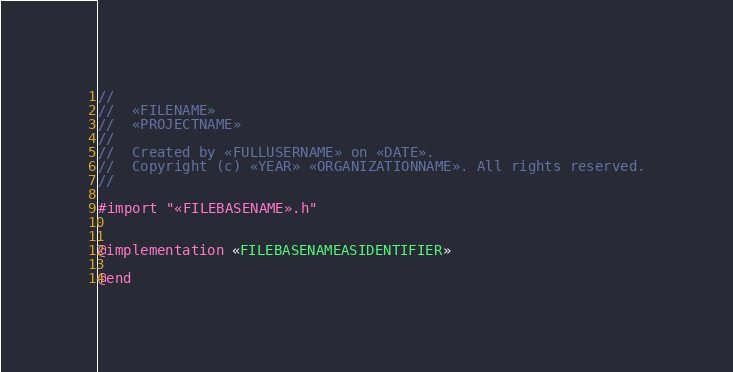Convert code to text. <code><loc_0><loc_0><loc_500><loc_500><_ObjectiveC_>//
//  «FILENAME»
//  «PROJECTNAME»
//
//  Created by «FULLUSERNAME» on «DATE».
//  Copyright (c) «YEAR» «ORGANIZATIONNAME». All rights reserved.
//

#import "«FILEBASENAME».h"


@implementation «FILEBASENAMEASIDENTIFIER»

@end
</code> 